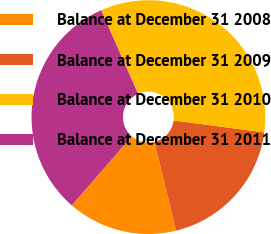<chart> <loc_0><loc_0><loc_500><loc_500><pie_chart><fcel>Balance at December 31 2008<fcel>Balance at December 31 2009<fcel>Balance at December 31 2010<fcel>Balance at December 31 2011<nl><fcel>15.18%<fcel>19.11%<fcel>33.72%<fcel>31.99%<nl></chart> 